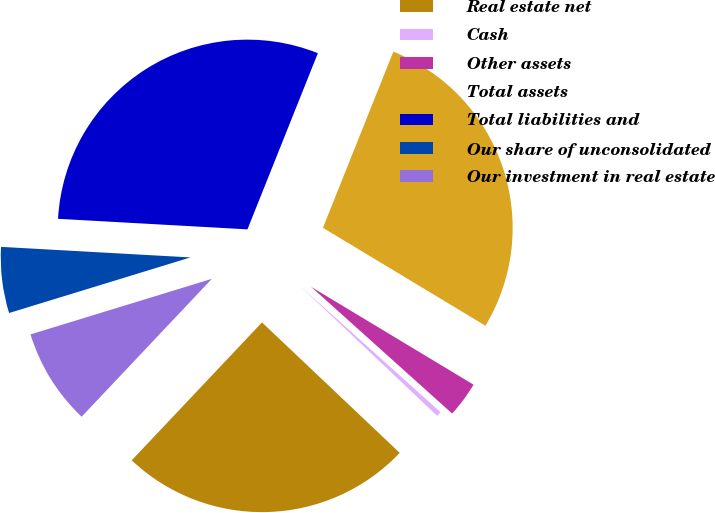Convert chart. <chart><loc_0><loc_0><loc_500><loc_500><pie_chart><fcel>Real estate net<fcel>Cash<fcel>Other assets<fcel>Total assets<fcel>Total liabilities and<fcel>Our share of unconsolidated<fcel>Our investment in real estate<nl><fcel>24.98%<fcel>0.42%<fcel>3.02%<fcel>27.58%<fcel>30.17%<fcel>5.62%<fcel>8.22%<nl></chart> 